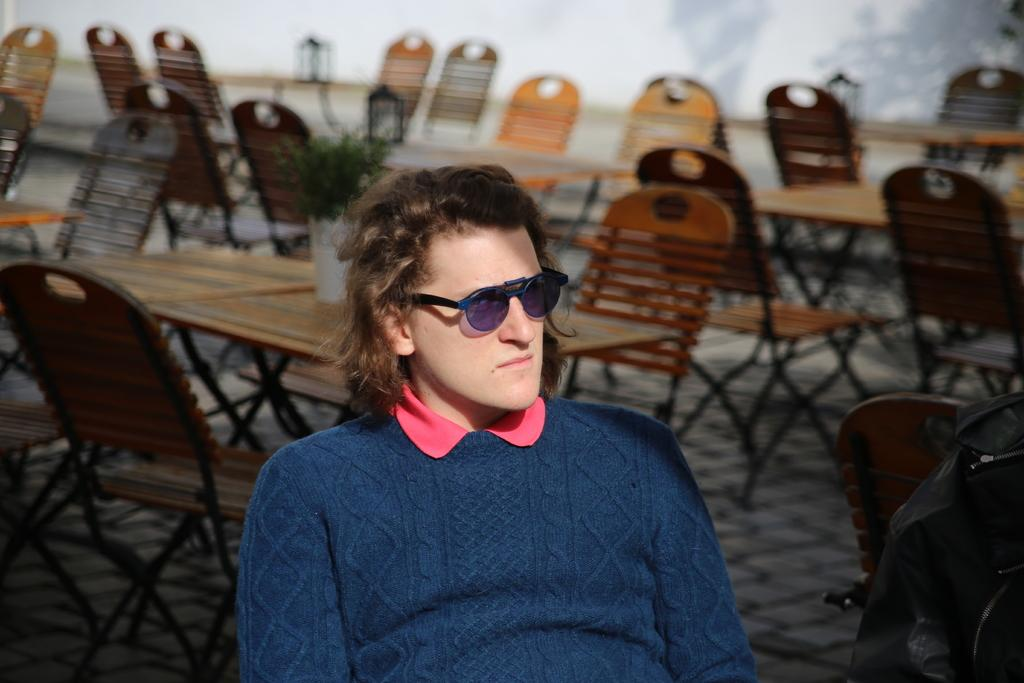What is the person in the image wearing? The person is wearing a navy blue sweatshirt. Where is the person sitting in relation to the other objects in the image? The person is sitting in the front. What type of furniture can be seen in the image? There are many tables and chairs visible in the image. What type of tooth is visible in the image? There is no tooth visible in the image. Where is the middle of the image located? The concept of a "middle" of the image is abstract and cannot be definitively determined from the provided facts. 